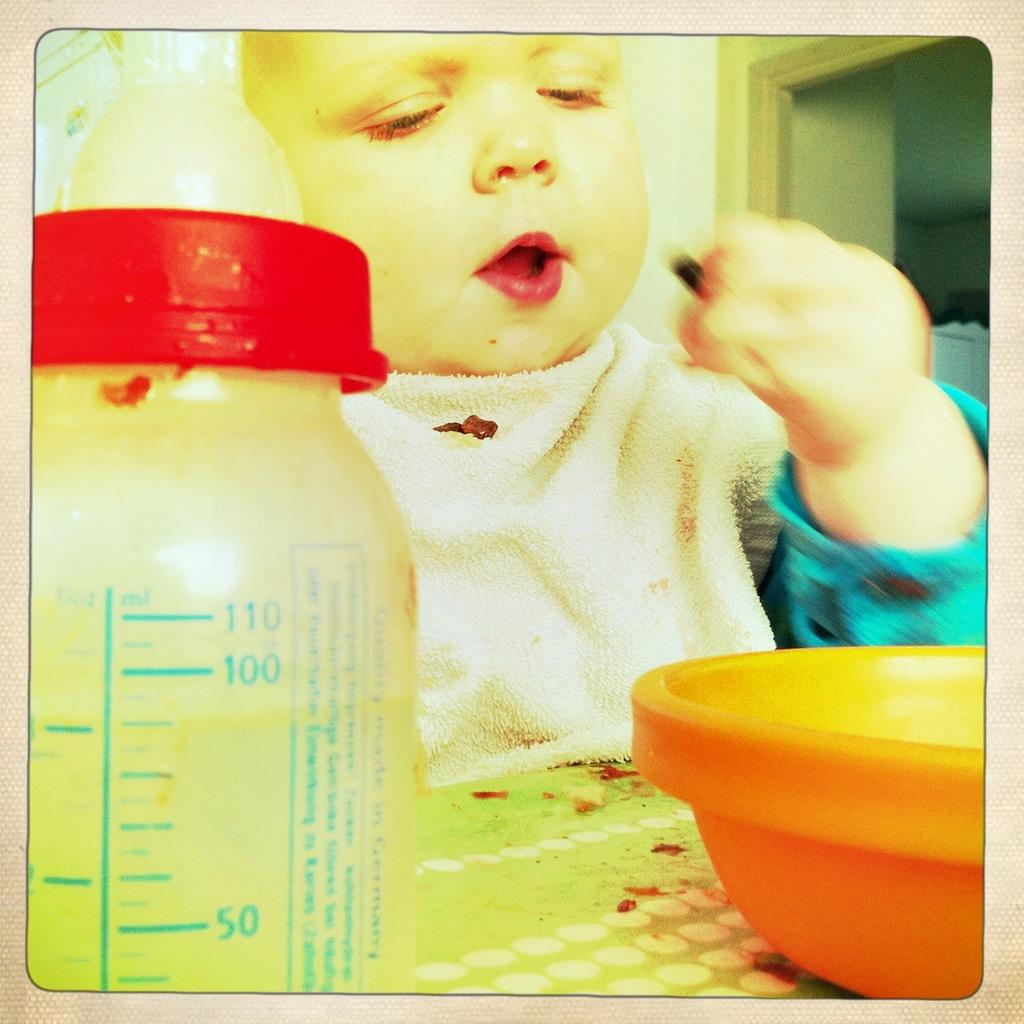What is the main subject of the image? The main subject of the image is a kid. Where is the kid located in the image? The kid is sitting in front of a table. What objects are on the table in the image? There is a bowl and a milk bottle on the table. What type of ink is the kid using to learn in the image? There is no ink or learning activity depicted in the image; it simply shows a kid sitting in front of a table with a bowl and a milk bottle. 